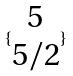<formula> <loc_0><loc_0><loc_500><loc_500>\{ \begin{matrix} 5 \\ 5 / 2 \end{matrix} \}</formula> 